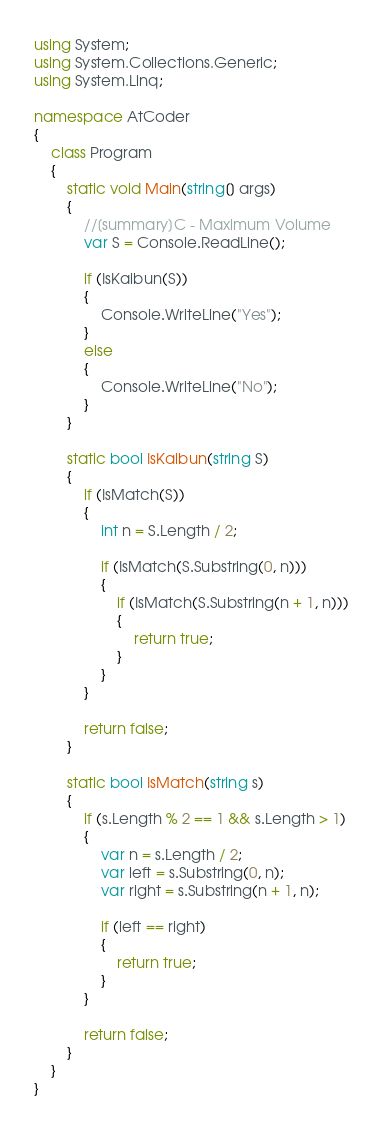<code> <loc_0><loc_0><loc_500><loc_500><_C#_>using System;
using System.Collections.Generic;
using System.Linq;

namespace AtCoder
{
    class Program
    {
        static void Main(string[] args)
        {
            //[summary]C - Maximum Volume
            var S = Console.ReadLine();

            if (IsKaibun(S))
            {
                Console.WriteLine("Yes");
            }
            else
            {
                Console.WriteLine("No");
            }
        }

        static bool IsKaibun(string S)
        {
            if (IsMatch(S))
            {
                int n = S.Length / 2;

                if (IsMatch(S.Substring(0, n)))
                {
                    if (IsMatch(S.Substring(n + 1, n)))
                    {
                        return true;
                    }
                }
            }

            return false;
        }

        static bool IsMatch(string s)
        {
            if (s.Length % 2 == 1 && s.Length > 1)
            {
                var n = s.Length / 2;
                var left = s.Substring(0, n);
                var right = s.Substring(n + 1, n);

                if (left == right)
                {
                    return true;
                }
            }

            return false;
        }
    }
}
</code> 